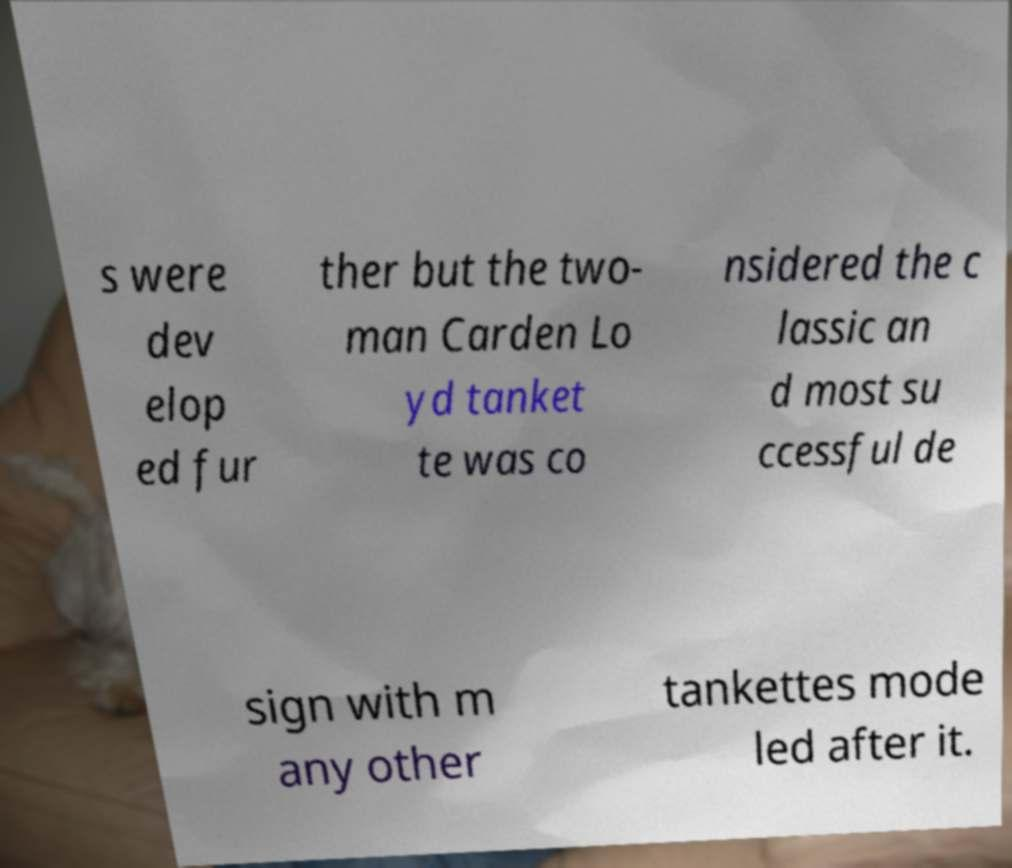Please identify and transcribe the text found in this image. s were dev elop ed fur ther but the two- man Carden Lo yd tanket te was co nsidered the c lassic an d most su ccessful de sign with m any other tankettes mode led after it. 